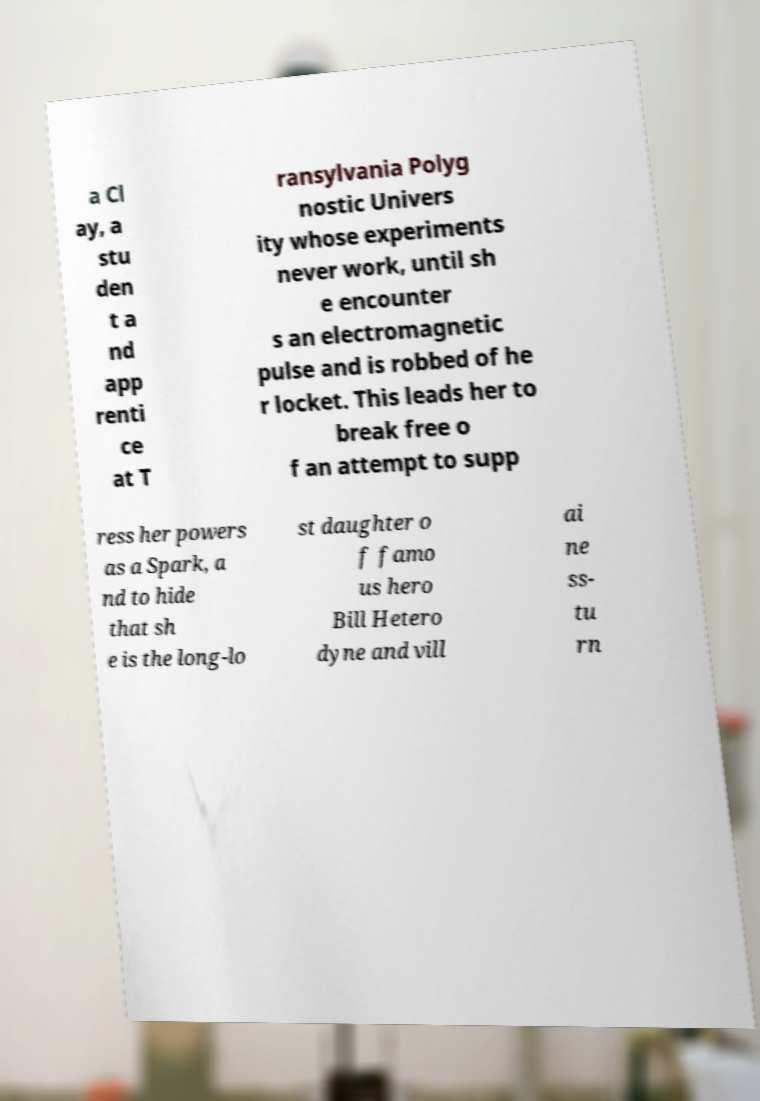Can you accurately transcribe the text from the provided image for me? a Cl ay, a stu den t a nd app renti ce at T ransylvania Polyg nostic Univers ity whose experiments never work, until sh e encounter s an electromagnetic pulse and is robbed of he r locket. This leads her to break free o f an attempt to supp ress her powers as a Spark, a nd to hide that sh e is the long-lo st daughter o f famo us hero Bill Hetero dyne and vill ai ne ss- tu rn 